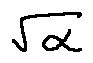Convert formula to latex. <formula><loc_0><loc_0><loc_500><loc_500>\sqrt { \alpha }</formula> 